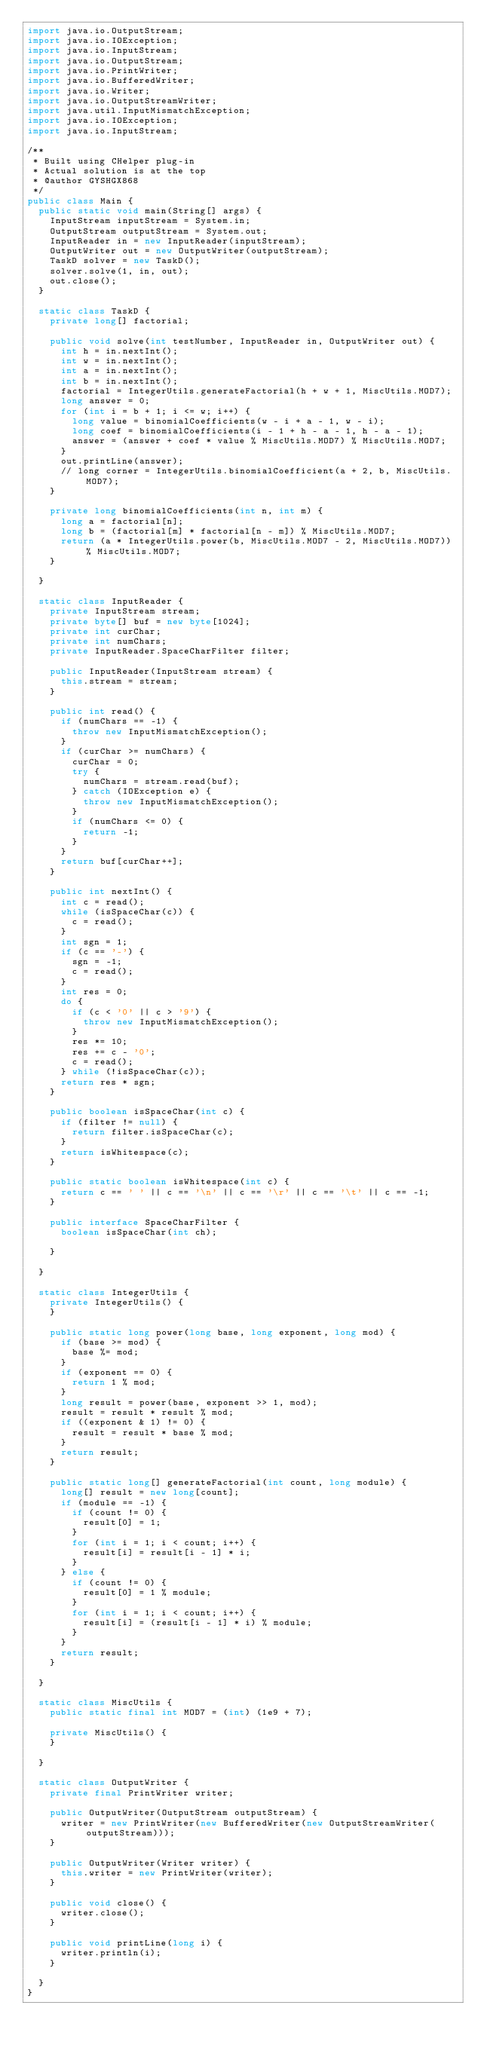Convert code to text. <code><loc_0><loc_0><loc_500><loc_500><_Java_>import java.io.OutputStream;
import java.io.IOException;
import java.io.InputStream;
import java.io.OutputStream;
import java.io.PrintWriter;
import java.io.BufferedWriter;
import java.io.Writer;
import java.io.OutputStreamWriter;
import java.util.InputMismatchException;
import java.io.IOException;
import java.io.InputStream;

/**
 * Built using CHelper plug-in
 * Actual solution is at the top
 * @author GYSHGX868
 */
public class Main {
  public static void main(String[] args) {
    InputStream inputStream = System.in;
    OutputStream outputStream = System.out;
    InputReader in = new InputReader(inputStream);
    OutputWriter out = new OutputWriter(outputStream);
    TaskD solver = new TaskD();
    solver.solve(1, in, out);
    out.close();
  }

  static class TaskD {
    private long[] factorial;

    public void solve(int testNumber, InputReader in, OutputWriter out) {
      int h = in.nextInt();
      int w = in.nextInt();
      int a = in.nextInt();
      int b = in.nextInt();
      factorial = IntegerUtils.generateFactorial(h + w + 1, MiscUtils.MOD7);
      long answer = 0;
      for (int i = b + 1; i <= w; i++) {
        long value = binomialCoefficients(w - i + a - 1, w - i);
        long coef = binomialCoefficients(i - 1 + h - a - 1, h - a - 1);
        answer = (answer + coef * value % MiscUtils.MOD7) % MiscUtils.MOD7;
      }
      out.printLine(answer);
      // long corner = IntegerUtils.binomialCoefficient(a + 2, b, MiscUtils.MOD7);
    }

    private long binomialCoefficients(int n, int m) {
      long a = factorial[n];
      long b = (factorial[m] * factorial[n - m]) % MiscUtils.MOD7;
      return (a * IntegerUtils.power(b, MiscUtils.MOD7 - 2, MiscUtils.MOD7)) % MiscUtils.MOD7;
    }

  }

  static class InputReader {
    private InputStream stream;
    private byte[] buf = new byte[1024];
    private int curChar;
    private int numChars;
    private InputReader.SpaceCharFilter filter;

    public InputReader(InputStream stream) {
      this.stream = stream;
    }

    public int read() {
      if (numChars == -1) {
        throw new InputMismatchException();
      }
      if (curChar >= numChars) {
        curChar = 0;
        try {
          numChars = stream.read(buf);
        } catch (IOException e) {
          throw new InputMismatchException();
        }
        if (numChars <= 0) {
          return -1;
        }
      }
      return buf[curChar++];
    }

    public int nextInt() {
      int c = read();
      while (isSpaceChar(c)) {
        c = read();
      }
      int sgn = 1;
      if (c == '-') {
        sgn = -1;
        c = read();
      }
      int res = 0;
      do {
        if (c < '0' || c > '9') {
          throw new InputMismatchException();
        }
        res *= 10;
        res += c - '0';
        c = read();
      } while (!isSpaceChar(c));
      return res * sgn;
    }

    public boolean isSpaceChar(int c) {
      if (filter != null) {
        return filter.isSpaceChar(c);
      }
      return isWhitespace(c);
    }

    public static boolean isWhitespace(int c) {
      return c == ' ' || c == '\n' || c == '\r' || c == '\t' || c == -1;
    }

    public interface SpaceCharFilter {
      boolean isSpaceChar(int ch);

    }

  }

  static class IntegerUtils {
    private IntegerUtils() {
    }
    
    public static long power(long base, long exponent, long mod) {
      if (base >= mod) {
        base %= mod;
      }
      if (exponent == 0) {
        return 1 % mod;
      }
      long result = power(base, exponent >> 1, mod);
      result = result * result % mod;
      if ((exponent & 1) != 0) {
        result = result * base % mod;
      }
      return result;
    }

    public static long[] generateFactorial(int count, long module) {
      long[] result = new long[count];
      if (module == -1) {
        if (count != 0) {
          result[0] = 1;
        }
        for (int i = 1; i < count; i++) {
          result[i] = result[i - 1] * i;
        }
      } else {
        if (count != 0) {
          result[0] = 1 % module;
        }
        for (int i = 1; i < count; i++) {
          result[i] = (result[i - 1] * i) % module;
        }
      }
      return result;
    }

  }

  static class MiscUtils {
    public static final int MOD7 = (int) (1e9 + 7);

    private MiscUtils() {
    }

  }

  static class OutputWriter {
    private final PrintWriter writer;

    public OutputWriter(OutputStream outputStream) {
      writer = new PrintWriter(new BufferedWriter(new OutputStreamWriter(outputStream)));
    }

    public OutputWriter(Writer writer) {
      this.writer = new PrintWriter(writer);
    }

    public void close() {
      writer.close();
    }

    public void printLine(long i) {
      writer.println(i);
    }

  }
}

</code> 